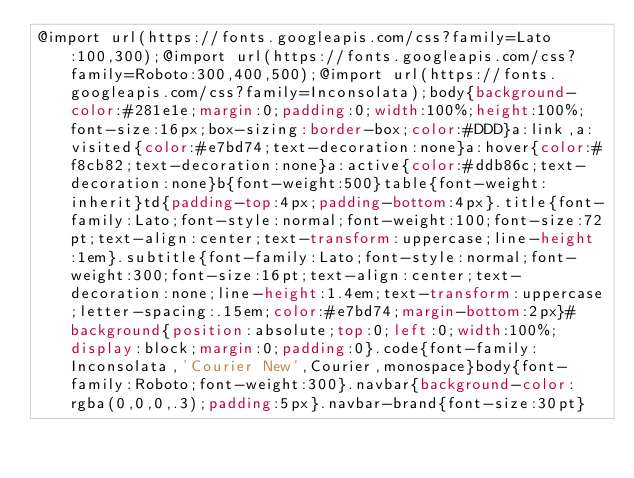Convert code to text. <code><loc_0><loc_0><loc_500><loc_500><_CSS_>@import url(https://fonts.googleapis.com/css?family=Lato:100,300);@import url(https://fonts.googleapis.com/css?family=Roboto:300,400,500);@import url(https://fonts.googleapis.com/css?family=Inconsolata);body{background-color:#281e1e;margin:0;padding:0;width:100%;height:100%;font-size:16px;box-sizing:border-box;color:#DDD}a:link,a:visited{color:#e7bd74;text-decoration:none}a:hover{color:#f8cb82;text-decoration:none}a:active{color:#ddb86c;text-decoration:none}b{font-weight:500}table{font-weight:inherit}td{padding-top:4px;padding-bottom:4px}.title{font-family:Lato;font-style:normal;font-weight:100;font-size:72pt;text-align:center;text-transform:uppercase;line-height:1em}.subtitle{font-family:Lato;font-style:normal;font-weight:300;font-size:16pt;text-align:center;text-decoration:none;line-height:1.4em;text-transform:uppercase;letter-spacing:.15em;color:#e7bd74;margin-bottom:2px}#background{position:absolute;top:0;left:0;width:100%;display:block;margin:0;padding:0}.code{font-family:Inconsolata,'Courier New',Courier,monospace}body{font-family:Roboto;font-weight:300}.navbar{background-color:rgba(0,0,0,.3);padding:5px}.navbar-brand{font-size:30pt}</code> 